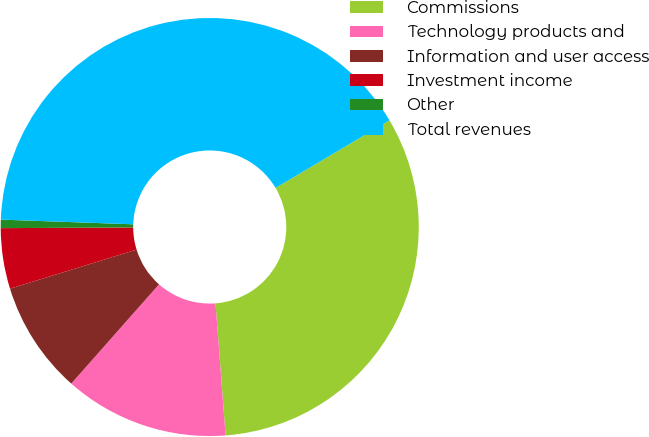Convert chart. <chart><loc_0><loc_0><loc_500><loc_500><pie_chart><fcel>Commissions<fcel>Technology products and<fcel>Information and user access<fcel>Investment income<fcel>Other<fcel>Total revenues<nl><fcel>32.32%<fcel>12.73%<fcel>8.71%<fcel>4.68%<fcel>0.65%<fcel>40.91%<nl></chart> 